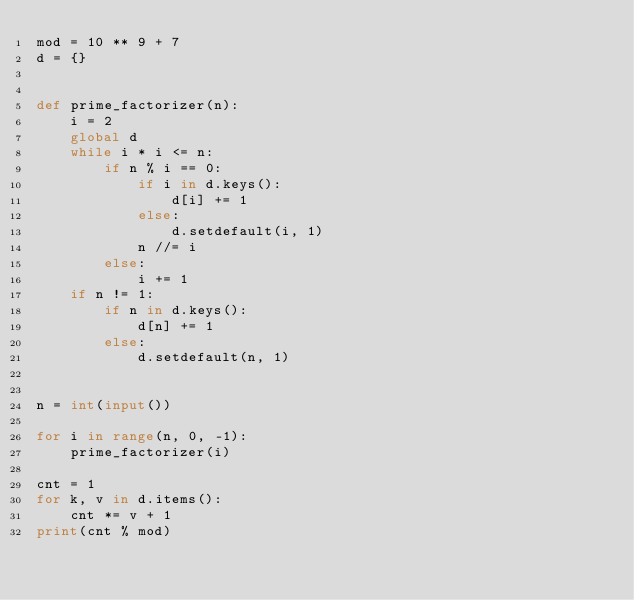Convert code to text. <code><loc_0><loc_0><loc_500><loc_500><_Python_>mod = 10 ** 9 + 7
d = {}


def prime_factorizer(n):
    i = 2
    global d
    while i * i <= n:
        if n % i == 0:
            if i in d.keys():
                d[i] += 1
            else:
                d.setdefault(i, 1)
            n //= i
        else:
            i += 1
    if n != 1:
        if n in d.keys():
            d[n] += 1
        else:
            d.setdefault(n, 1)


n = int(input())

for i in range(n, 0, -1):
    prime_factorizer(i)

cnt = 1
for k, v in d.items():
    cnt *= v + 1
print(cnt % mod)
</code> 